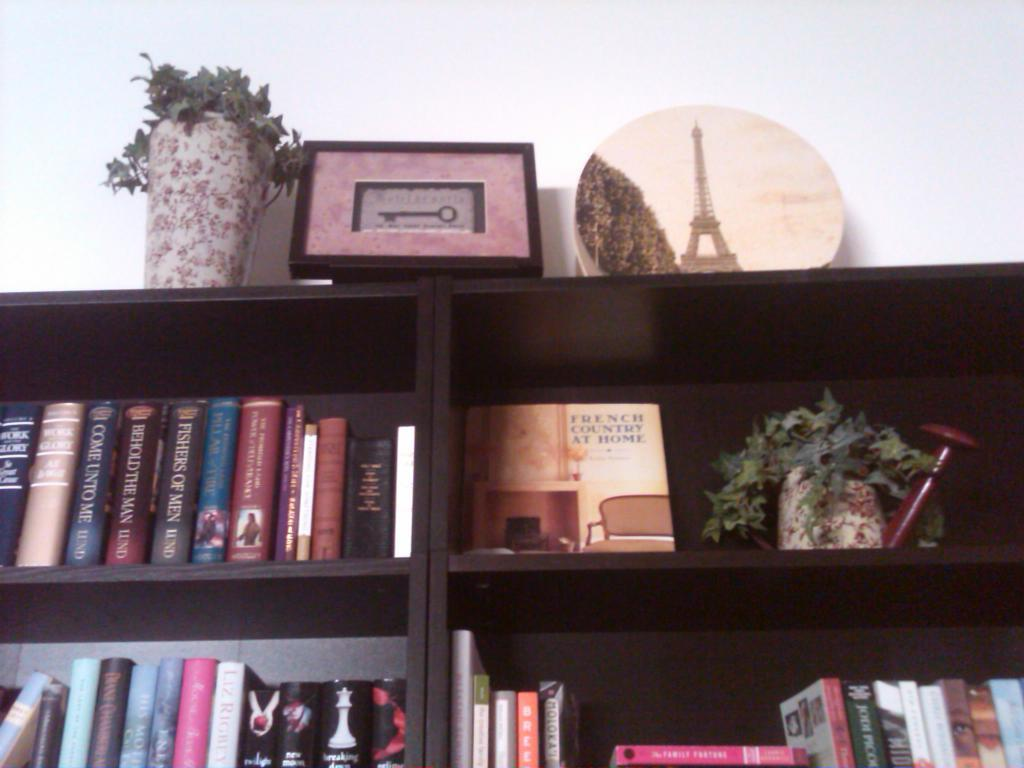<image>
Write a terse but informative summary of the picture. A rack with lots of book and one of them is about french country at home. 